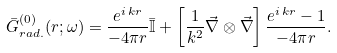<formula> <loc_0><loc_0><loc_500><loc_500>\bar { G } _ { r a d . } ^ { ( 0 ) } ( r ; \omega ) = \frac { e ^ { i \, k r } } { - 4 \pi r } \bar { \mathbb { I } } + \left [ \frac { 1 } { k ^ { 2 } } \vec { \nabla } \otimes \vec { \nabla } \right ] \frac { e ^ { i \, k r } - 1 } { - 4 \pi r } .</formula> 